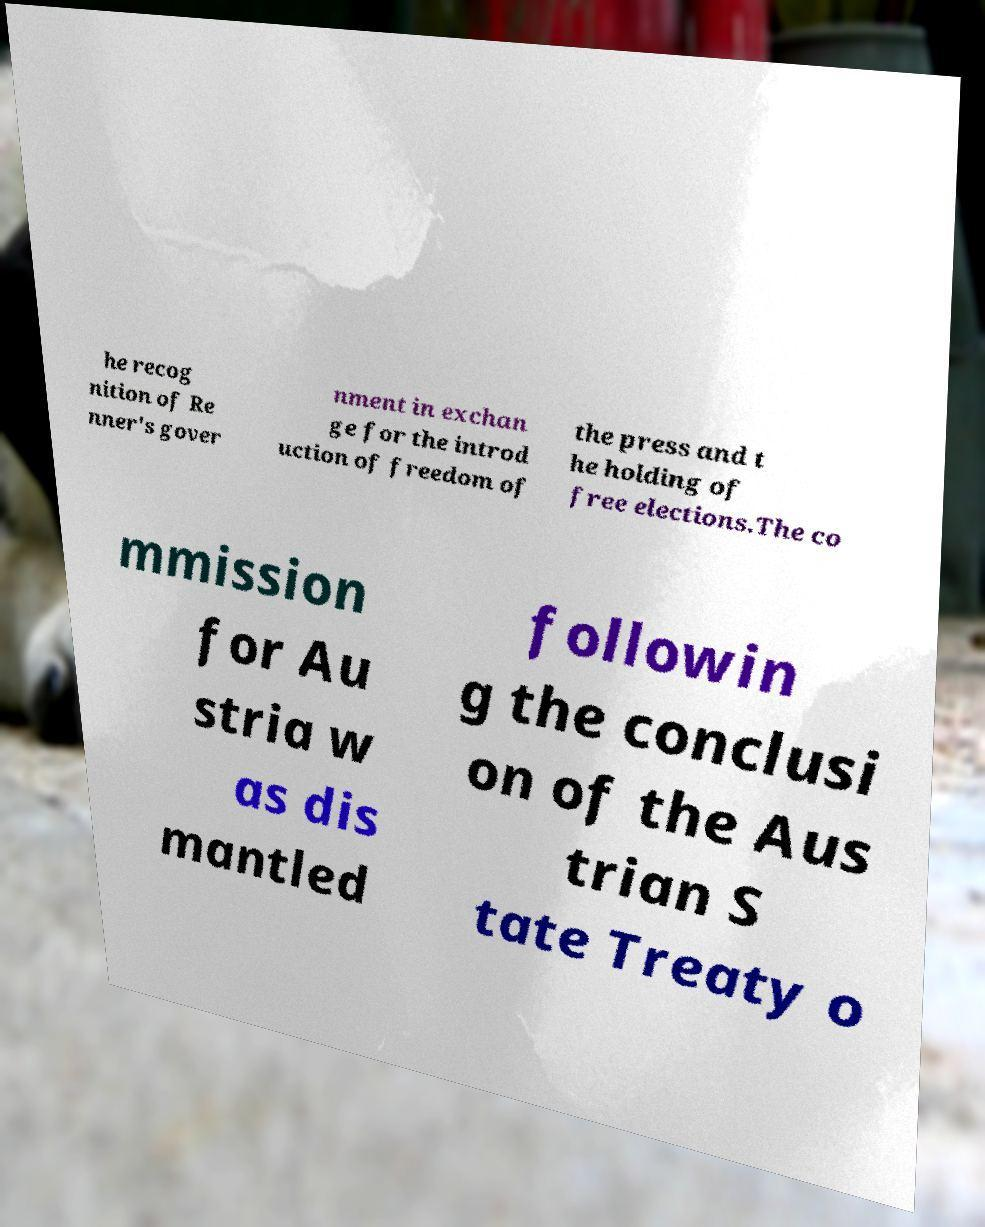Could you extract and type out the text from this image? he recog nition of Re nner's gover nment in exchan ge for the introd uction of freedom of the press and t he holding of free elections.The co mmission for Au stria w as dis mantled followin g the conclusi on of the Aus trian S tate Treaty o 